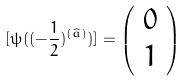<formula> <loc_0><loc_0><loc_500><loc_500>[ \psi ( ( - \frac { 1 } { 2 } ) ^ { ( \widehat { a } ) } ) ] = \left ( \begin{array} { c } 0 \\ 1 \end{array} \right )</formula> 